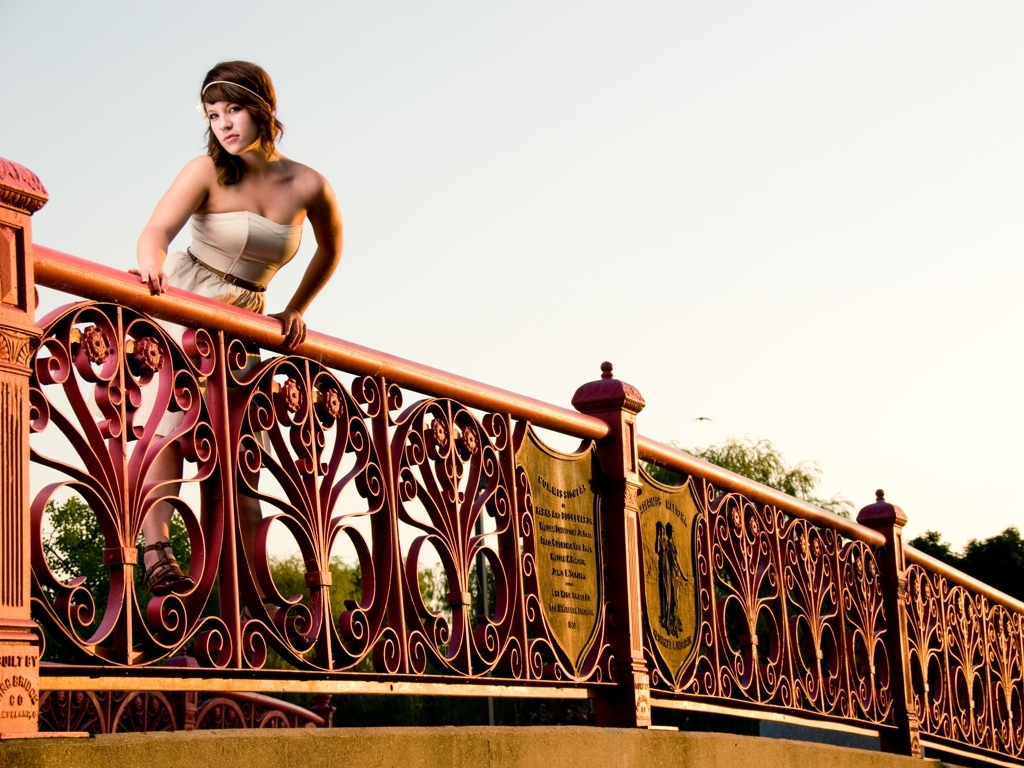What significance can be inferred from the plaques on the railing? The plaques on the railing add a layer of historical significance to the scene, suggesting the bridge may be a landmark or hold a commemorative purpose. The inscriptions, although not entirely legible in this image, typically honor individuals or events and connote a sense of heritage and community pride. 